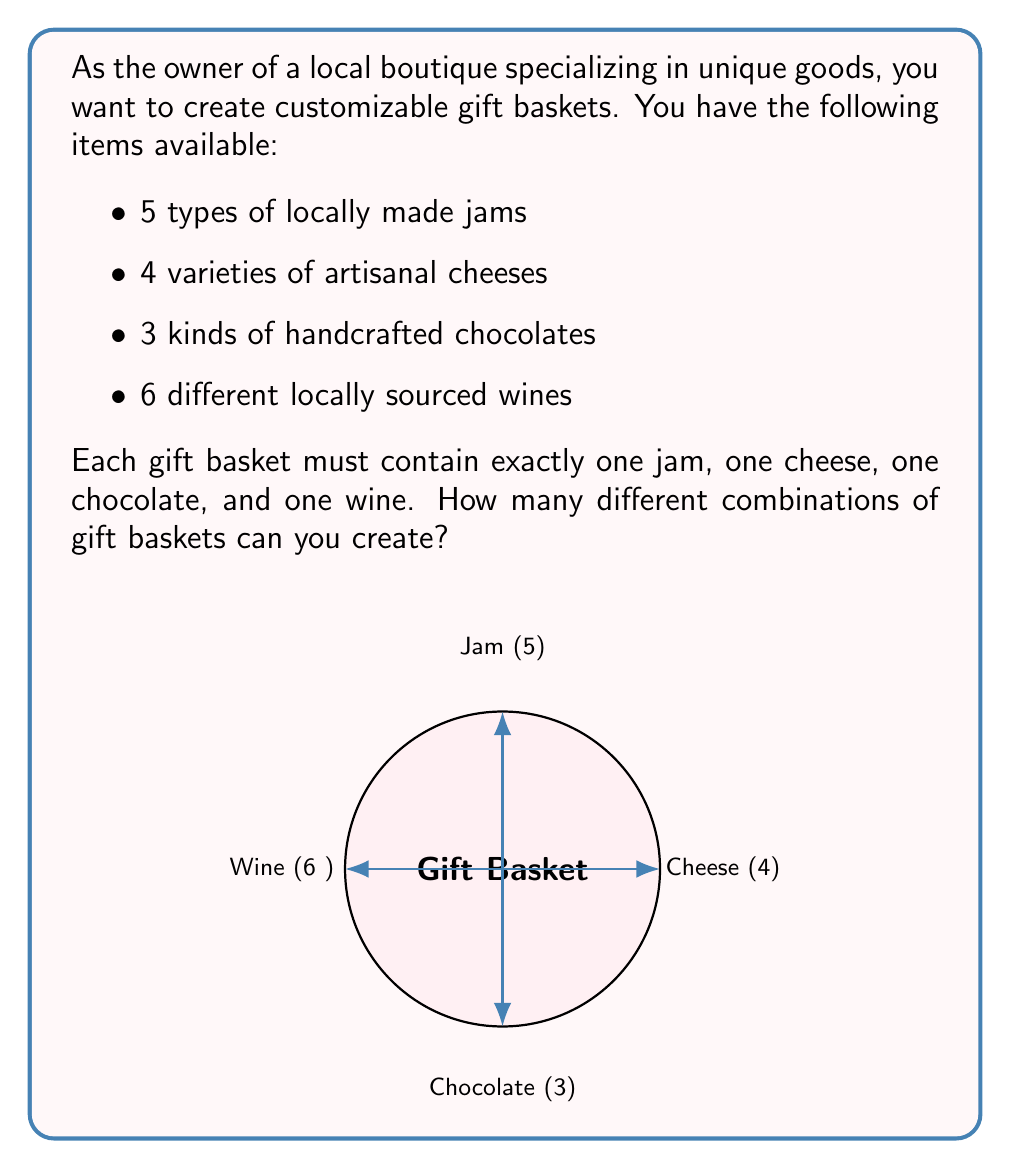Give your solution to this math problem. Let's approach this step-by-step using the multiplication principle of counting:

1) For each gift basket, we need to make four independent choices:
   - Choose 1 jam out of 5 options
   - Choose 1 cheese out of 4 options
   - Choose 1 chocolate out of 3 options
   - Choose 1 wine out of 6 options

2) The multiplication principle states that if we have a sequence of $n$ independent choices, where the $i$-th choice has $k_i$ options, then the total number of possible outcomes is the product of the number of options for each choice.

3) In this case, we have:
   - $k_1 = 5$ (jams)
   - $k_2 = 4$ (cheeses)
   - $k_3 = 3$ (chocolates)
   - $k_4 = 6$ (wines)

4) Therefore, the total number of different gift basket combinations is:

   $$5 \times 4 \times 3 \times 6$$

5) Calculating this:
   $$5 \times 4 \times 3 \times 6 = 360$$

Thus, you can create 360 different combinations of gift baskets.
Answer: 360 